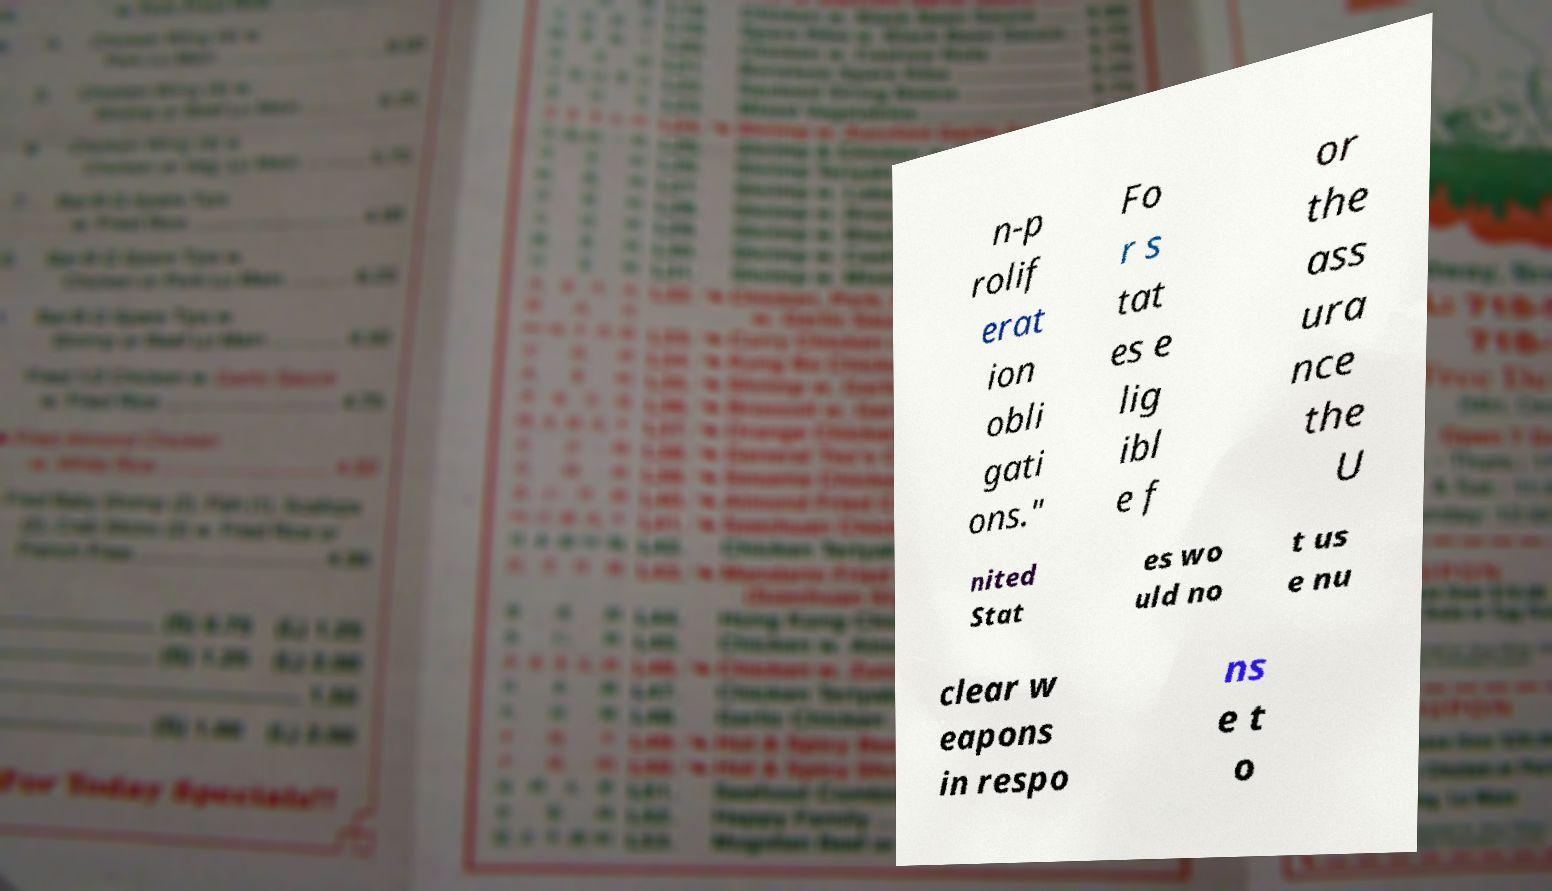Please read and relay the text visible in this image. What does it say? n-p rolif erat ion obli gati ons." Fo r s tat es e lig ibl e f or the ass ura nce the U nited Stat es wo uld no t us e nu clear w eapons in respo ns e t o 